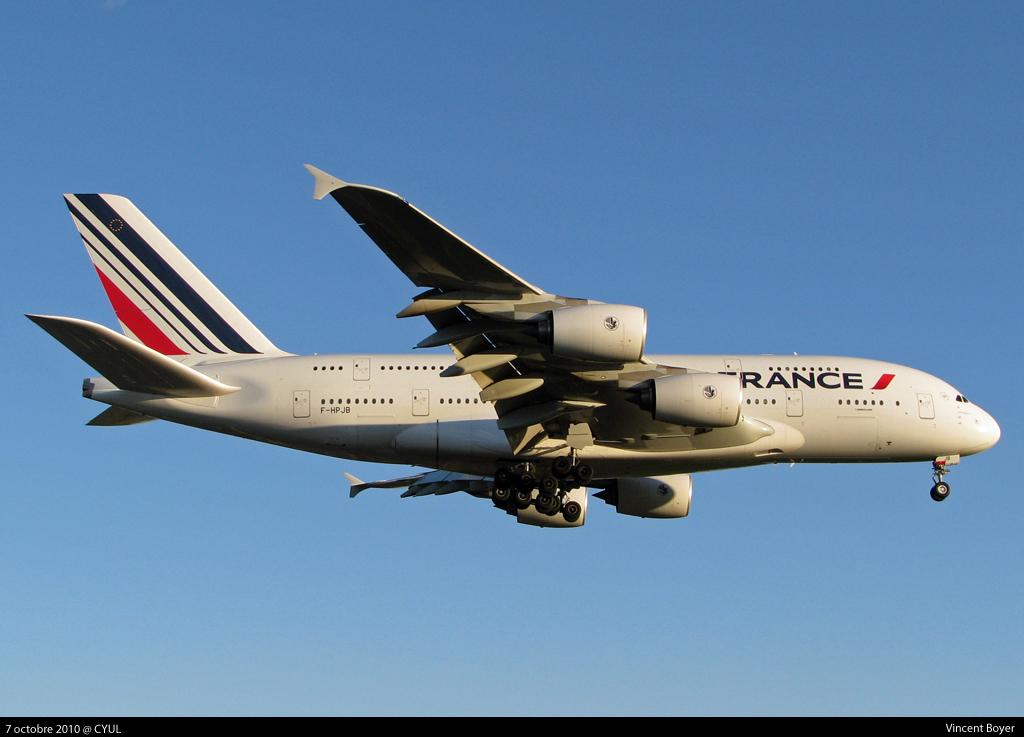What country is on the front of this plane?
Offer a terse response. France. What is this aircraft's registration number?
Your response must be concise. Unanswerable. 